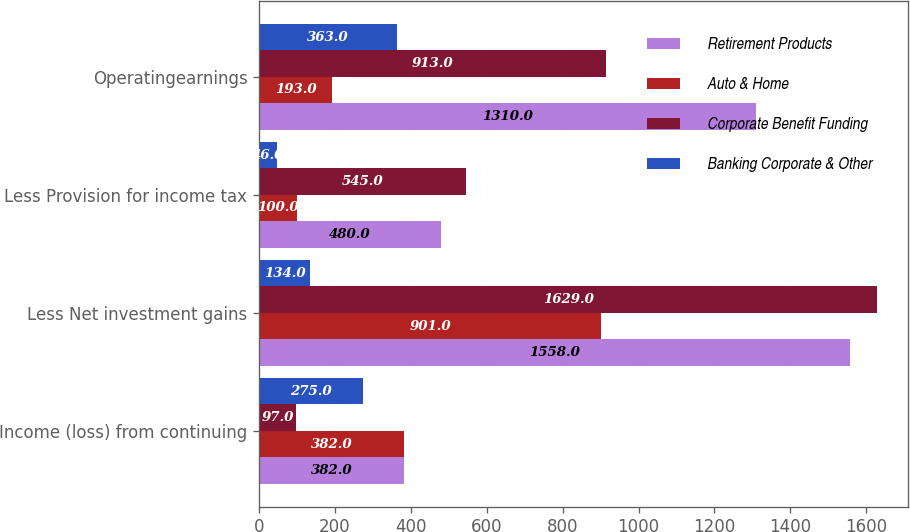Convert chart. <chart><loc_0><loc_0><loc_500><loc_500><stacked_bar_chart><ecel><fcel>Income (loss) from continuing<fcel>Less Net investment gains<fcel>Less Provision for income tax<fcel>Operatingearnings<nl><fcel>Retirement Products<fcel>382<fcel>1558<fcel>480<fcel>1310<nl><fcel>Auto & Home<fcel>382<fcel>901<fcel>100<fcel>193<nl><fcel>Corporate Benefit Funding<fcel>97<fcel>1629<fcel>545<fcel>913<nl><fcel>Banking Corporate & Other<fcel>275<fcel>134<fcel>46<fcel>363<nl></chart> 